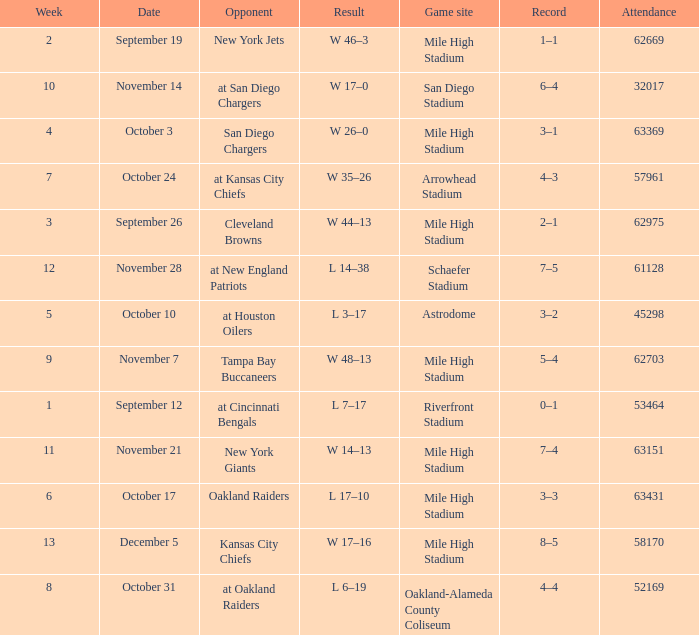When was the game held during the fourth week? October 3. 